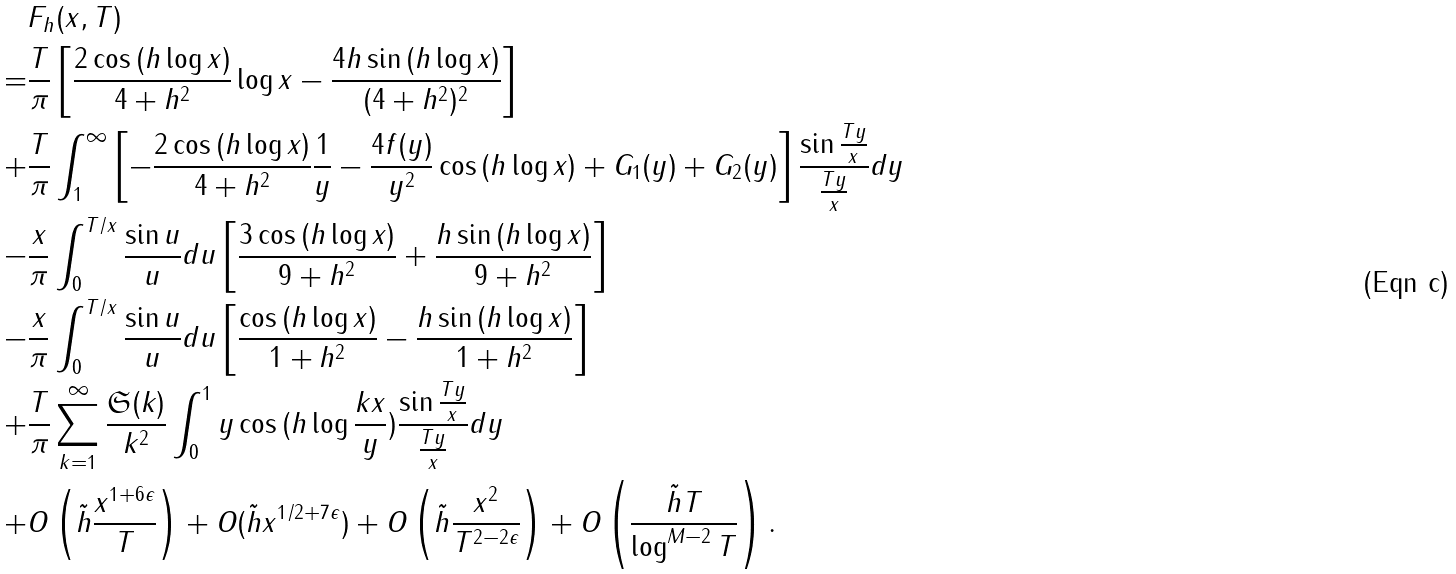<formula> <loc_0><loc_0><loc_500><loc_500>& F _ { h } ( x , T ) \\ = & \frac { T } { \pi } \left [ \frac { 2 \cos { ( h \log { x } ) } } { 4 + h ^ { 2 } } \log { x } - \frac { 4 h \sin { ( h \log { x } ) } } { ( 4 + h ^ { 2 } ) ^ { 2 } } \right ] \\ + & \frac { T } { \pi } \int _ { 1 } ^ { \infty } \left [ - \frac { 2 \cos { ( h \log { x } ) } } { 4 + h ^ { 2 } } \frac { 1 } { y } - \frac { 4 f ( y ) } { y ^ { 2 } } \cos { ( h \log { x } ) } + G _ { 1 } ( y ) + G _ { 2 } ( y ) \right ] \frac { \sin { \frac { T y } { x } } } { \frac { T y } { x } } d y \\ - & \frac { x } { \pi } \int _ { 0 } ^ { T / x } \frac { \sin { u } } { u } d u \left [ \frac { 3 \cos { ( h \log { x } ) } } { 9 + h ^ { 2 } } + \frac { h \sin { ( h \log { x } ) } } { 9 + h ^ { 2 } } \right ] \\ - & \frac { x } { \pi } \int _ { 0 } ^ { T / x } \frac { \sin { u } } { u } d u \left [ \frac { \cos { ( h \log { x } ) } } { 1 + h ^ { 2 } } - \frac { h \sin { ( h \log { x } ) } } { 1 + h ^ { 2 } } \right ] \\ + & \frac { T } { \pi } \sum _ { k = 1 } ^ { \infty } \frac { { \mathfrak S } ( k ) } { k ^ { 2 } } \int _ { 0 } ^ { 1 } y \cos { ( h \log { \frac { k x } { y } } ) } \frac { \sin { \frac { T y } { x } } } { \frac { T y } { x } } d y \\ + & O \left ( \tilde { h } \frac { x ^ { 1 + 6 \epsilon } } { T } \right ) + O ( \tilde { h } x ^ { 1 / 2 + 7 \epsilon } ) + O \left ( \tilde { h } \frac { x ^ { 2 } } { T ^ { 2 - 2 \epsilon } } \right ) + O \left ( \frac { \tilde { h } T } { \log ^ { M - 2 } { T } } \right ) .</formula> 